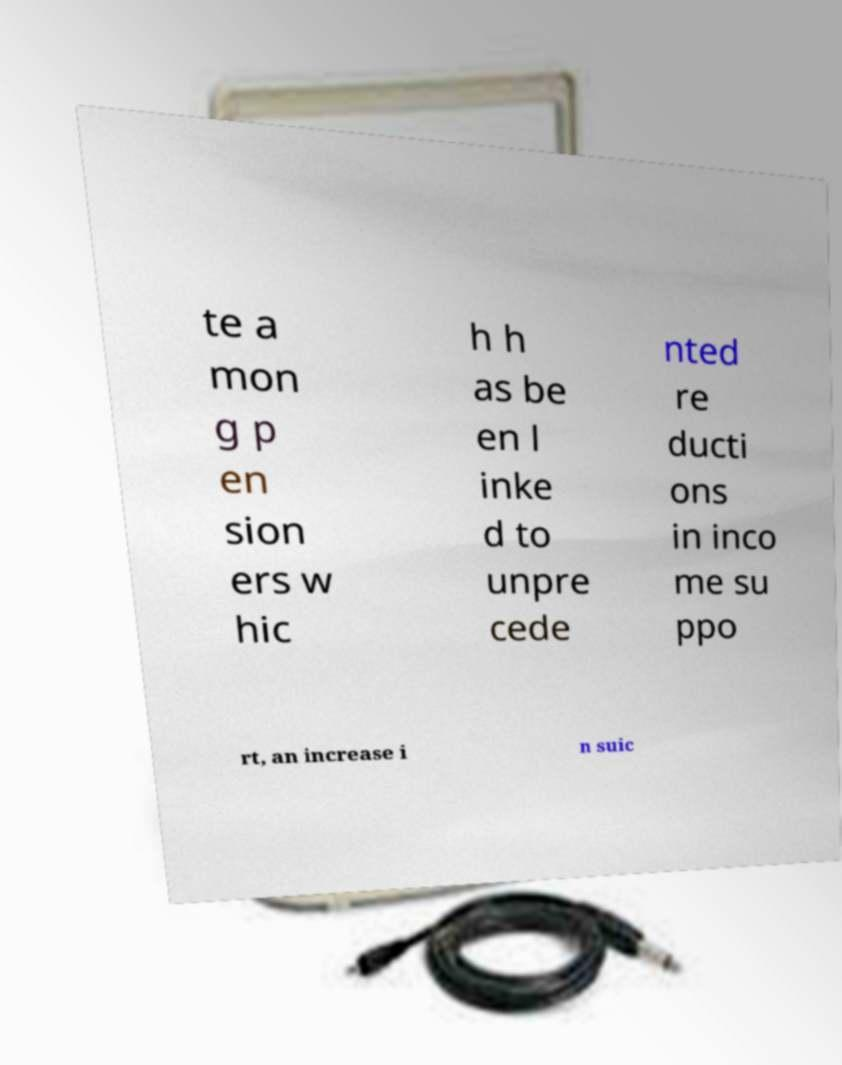I need the written content from this picture converted into text. Can you do that? te a mon g p en sion ers w hic h h as be en l inke d to unpre cede nted re ducti ons in inco me su ppo rt, an increase i n suic 